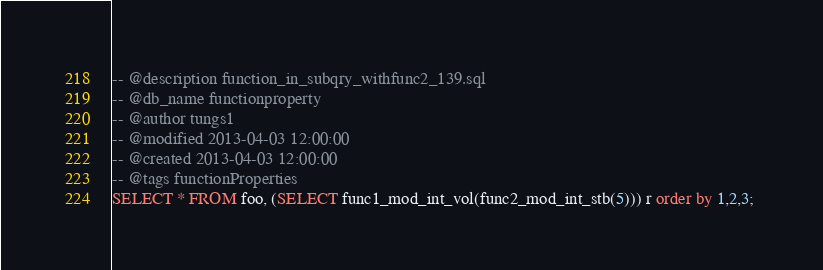Convert code to text. <code><loc_0><loc_0><loc_500><loc_500><_SQL_>-- @description function_in_subqry_withfunc2_139.sql
-- @db_name functionproperty
-- @author tungs1
-- @modified 2013-04-03 12:00:00
-- @created 2013-04-03 12:00:00
-- @tags functionProperties 
SELECT * FROM foo, (SELECT func1_mod_int_vol(func2_mod_int_stb(5))) r order by 1,2,3; 
</code> 